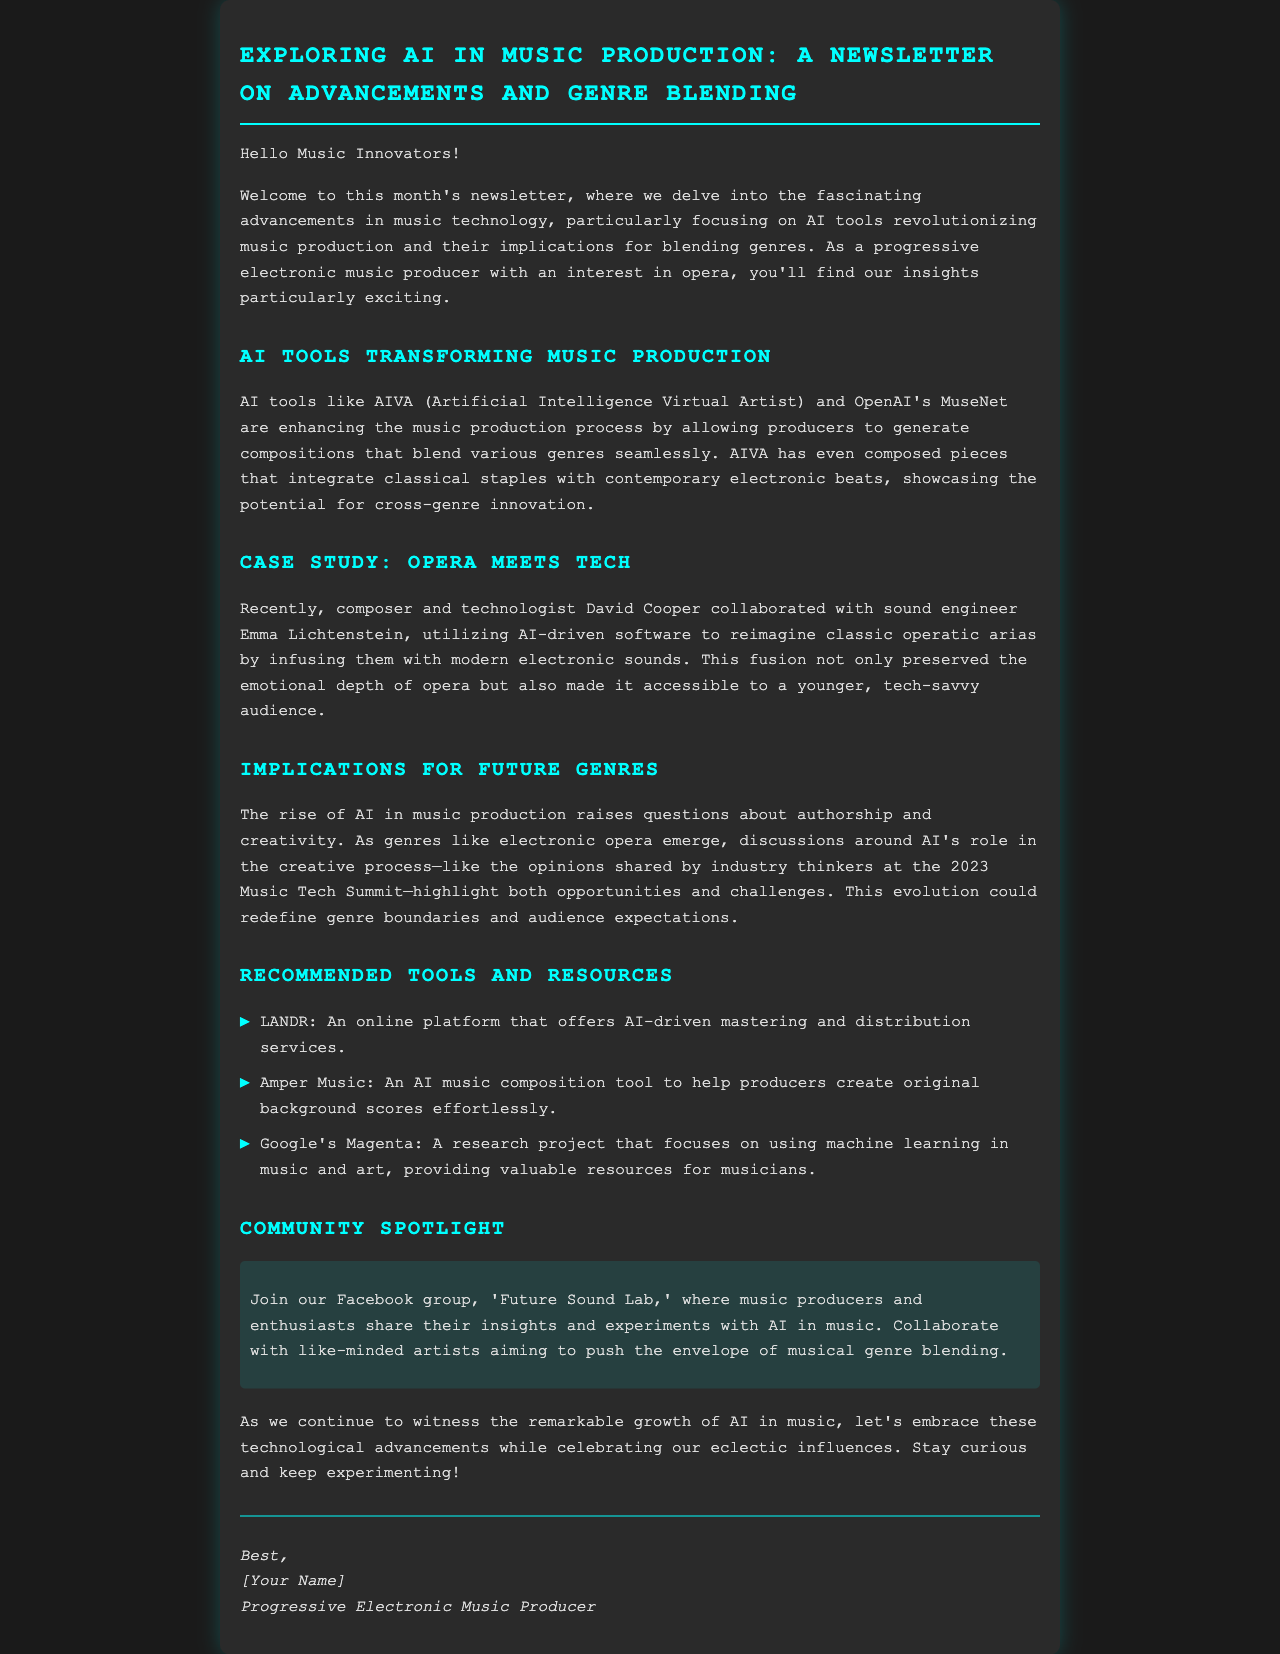What is the name of the AI tool that enhances the music production process? AIVA is mentioned as an AI tool enhancing music production by generating compositions.
Answer: AIVA Who collaborated with Emma Lichtenstein in the case study? The document states that composer David Cooper collaborated with sound engineer Emma Lichtenstein.
Answer: David Cooper What genre is discussed as blending with opera in the newsletter? The newsletter discusses how classical and contemporary electronic genres blend.
Answer: Electronic What platform is recommended for AI-driven mastering services? LANDR is mentioned as an online platform offering AI-driven mastering services.
Answer: LANDR What is the Facebook group mentioned in the newsletter? The group 'Future Sound Lab' is highlighted for collaboration among music producers and enthusiasts.
Answer: Future Sound Lab What kind of music genre could emerge due to AI's influence? The document suggests that genres like electronic opera could emerge from the rise of AI in music.
Answer: Electronic opera What year was the Music Tech Summit held? The newsletter references the opinions from the Music Tech Summit held in 2023.
Answer: 2023 What type of document is this? The structure and tone indicate that this is a newsletter focused on advancements in music technology.
Answer: Newsletter 